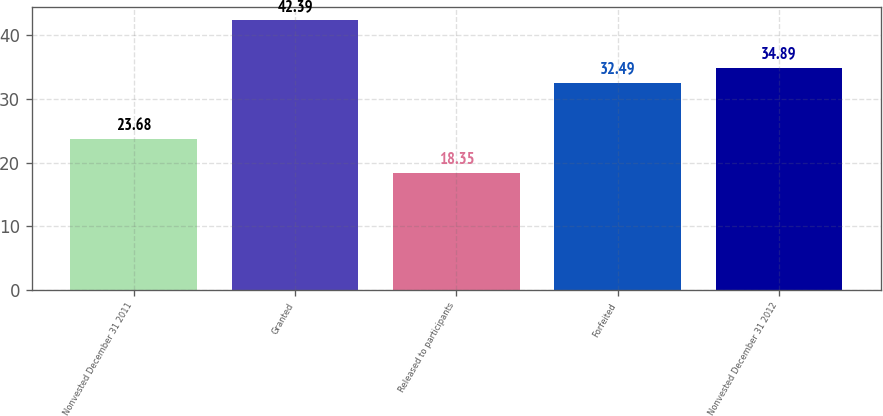Convert chart. <chart><loc_0><loc_0><loc_500><loc_500><bar_chart><fcel>Nonvested December 31 2011<fcel>Granted<fcel>Released to participants<fcel>Forfeited<fcel>Nonvested December 31 2012<nl><fcel>23.68<fcel>42.39<fcel>18.35<fcel>32.49<fcel>34.89<nl></chart> 